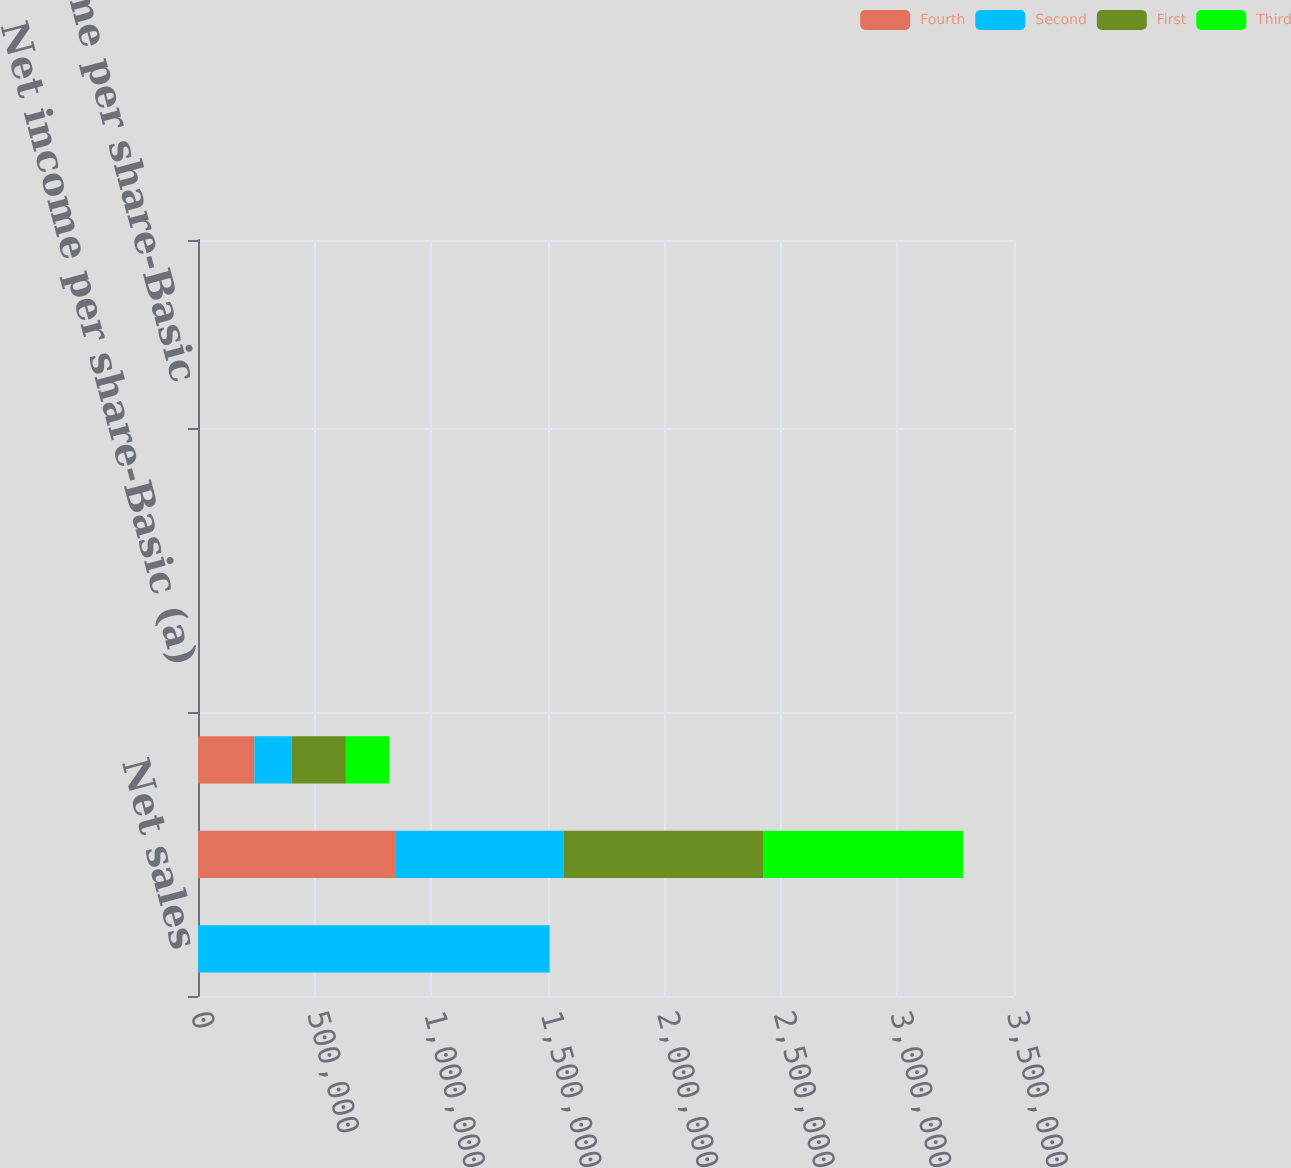Convert chart to OTSL. <chart><loc_0><loc_0><loc_500><loc_500><stacked_bar_chart><ecel><fcel>Net sales<fcel>Gross profit<fcel>Net income<fcel>Net income per share-Basic (a)<fcel>Net income per share-Diluted<fcel>Dividends paid per share<fcel>Net income per share-Basic<fcel>High<nl><fcel>Fourth<fcel>1.07<fcel>849337<fcel>241906<fcel>1.11<fcel>1.06<fcel>0.42<fcel>1<fcel>87.53<nl><fcel>Second<fcel>1.50851e+06<fcel>718574<fcel>159504<fcel>0.73<fcel>0.7<fcel>0.42<fcel>0.66<fcel>91.25<nl><fcel>First<fcel>1.07<fcel>855551<fcel>232985<fcel>1.07<fcel>1.03<fcel>0.48<fcel>0.96<fcel>97.69<nl><fcel>Third<fcel>1.07<fcel>857386<fcel>186075<fcel>0.85<fcel>0.82<fcel>0.48<fcel>0.77<fcel>100.9<nl></chart> 